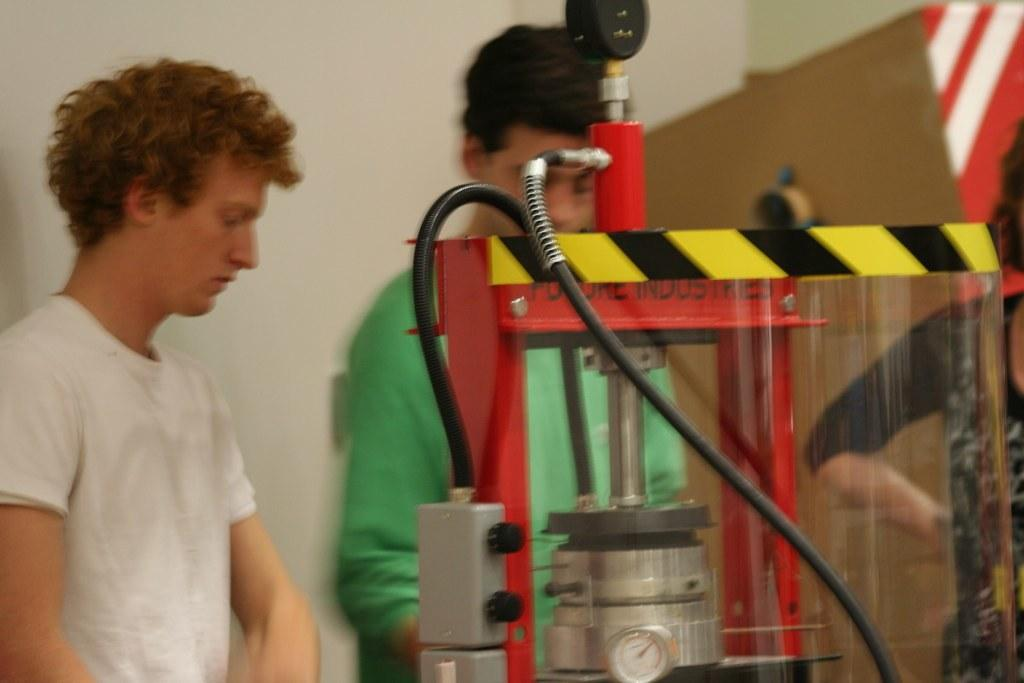How many people are visible in the image? There are three people visible in the image. Can you describe the position of the people in the image? Two people are standing together, and there is another person standing beside them. What is in front of the people in the image? There is a machine in front of the people. What can be seen in the background of the image? There is a wall in the background of the image. What type of suit is the turkey wearing in the image? There is no turkey present in the image, and therefore no suit can be observed. 